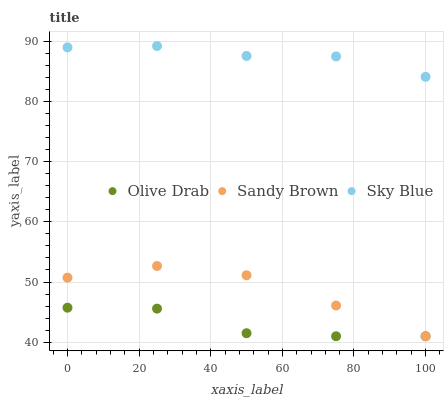Does Olive Drab have the minimum area under the curve?
Answer yes or no. Yes. Does Sky Blue have the maximum area under the curve?
Answer yes or no. Yes. Does Sandy Brown have the minimum area under the curve?
Answer yes or no. No. Does Sandy Brown have the maximum area under the curve?
Answer yes or no. No. Is Sky Blue the smoothest?
Answer yes or no. Yes. Is Olive Drab the roughest?
Answer yes or no. Yes. Is Sandy Brown the smoothest?
Answer yes or no. No. Is Sandy Brown the roughest?
Answer yes or no. No. Does Sandy Brown have the lowest value?
Answer yes or no. Yes. Does Sky Blue have the highest value?
Answer yes or no. Yes. Does Sandy Brown have the highest value?
Answer yes or no. No. Is Sandy Brown less than Sky Blue?
Answer yes or no. Yes. Is Sky Blue greater than Sandy Brown?
Answer yes or no. Yes. Does Sandy Brown intersect Olive Drab?
Answer yes or no. Yes. Is Sandy Brown less than Olive Drab?
Answer yes or no. No. Is Sandy Brown greater than Olive Drab?
Answer yes or no. No. Does Sandy Brown intersect Sky Blue?
Answer yes or no. No. 